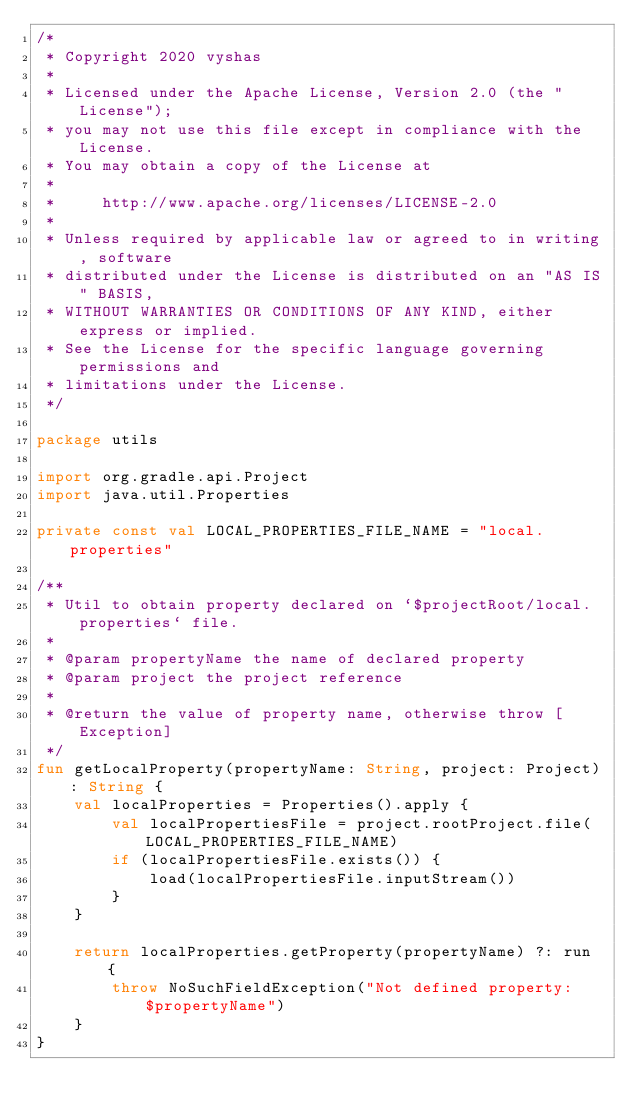Convert code to text. <code><loc_0><loc_0><loc_500><loc_500><_Kotlin_>/*
 * Copyright 2020 vyshas
 *
 * Licensed under the Apache License, Version 2.0 (the "License");
 * you may not use this file except in compliance with the License.
 * You may obtain a copy of the License at
 *
 *     http://www.apache.org/licenses/LICENSE-2.0
 *
 * Unless required by applicable law or agreed to in writing, software
 * distributed under the License is distributed on an "AS IS" BASIS,
 * WITHOUT WARRANTIES OR CONDITIONS OF ANY KIND, either express or implied.
 * See the License for the specific language governing permissions and
 * limitations under the License.
 */

package utils

import org.gradle.api.Project
import java.util.Properties

private const val LOCAL_PROPERTIES_FILE_NAME = "local.properties"

/**
 * Util to obtain property declared on `$projectRoot/local.properties` file.
 *
 * @param propertyName the name of declared property
 * @param project the project reference
 *
 * @return the value of property name, otherwise throw [Exception]
 */
fun getLocalProperty(propertyName: String, project: Project): String {
    val localProperties = Properties().apply {
        val localPropertiesFile = project.rootProject.file(LOCAL_PROPERTIES_FILE_NAME)
        if (localPropertiesFile.exists()) {
            load(localPropertiesFile.inputStream())
        }
    }

    return localProperties.getProperty(propertyName) ?: run {
        throw NoSuchFieldException("Not defined property: $propertyName")
    }
}
</code> 